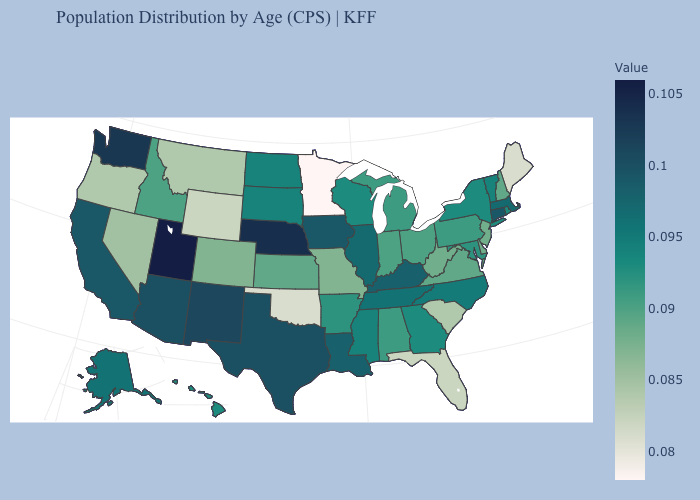Does the map have missing data?
Give a very brief answer. No. 